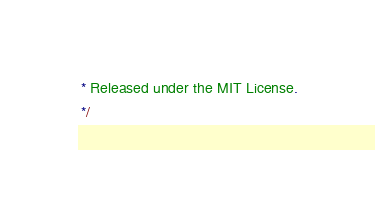Convert code to text. <code><loc_0><loc_0><loc_500><loc_500><_JavaScript_> * Released under the MIT License.
 */</code> 